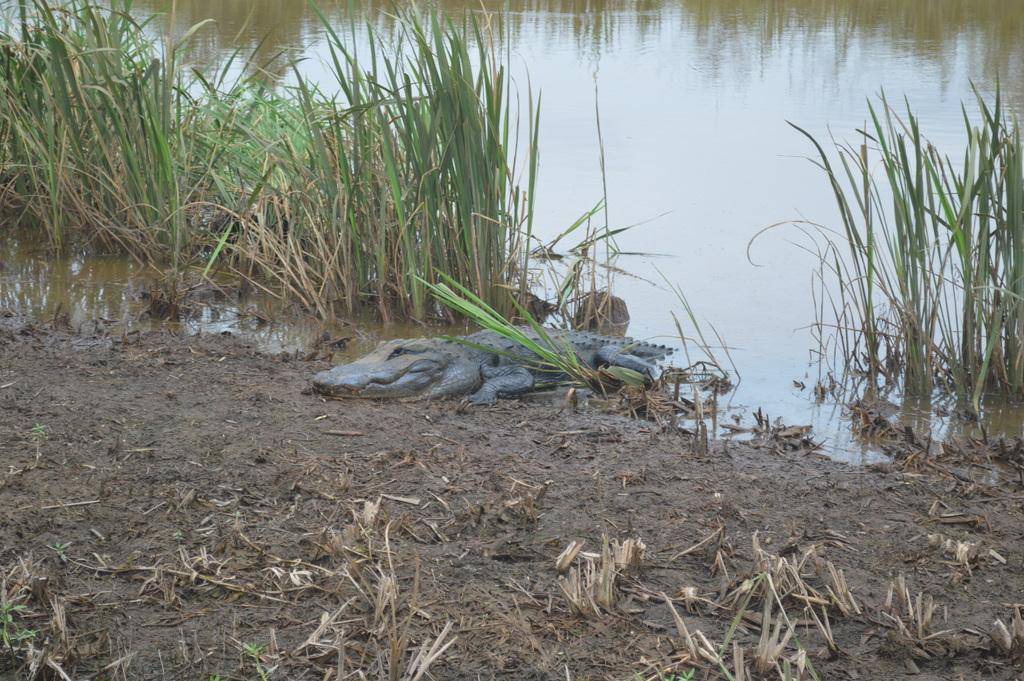What type of animal is in the image? There is a crocodile in the image. Where is the crocodile located in the image? The crocodile is on the ground. What type of vegetation is visible in the image? There is grass visible in the image. What type of natural environment is depicted in the image? There is water visible in the image, suggesting a wetland or similar environment. What type of volleyball game is being played in the image? There is no volleyball game present in the image. What type of meal is being prepared or served in the image? There is no meal preparation or serving depicted in the image. What type of pollution is visible in the image? There is no pollution visible in the image. 